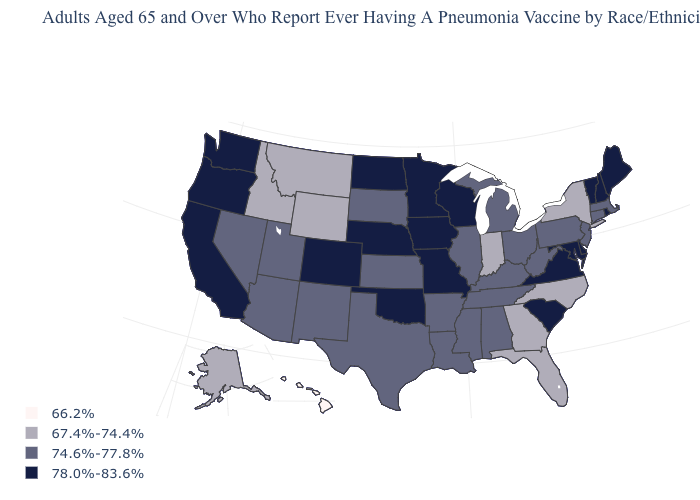Does Washington have the lowest value in the USA?
Keep it brief. No. Which states have the lowest value in the MidWest?
Answer briefly. Indiana. Does the map have missing data?
Quick response, please. No. Name the states that have a value in the range 66.2%?
Be succinct. Hawaii. Which states have the highest value in the USA?
Short answer required. California, Colorado, Delaware, Iowa, Maine, Maryland, Minnesota, Missouri, Nebraska, New Hampshire, North Dakota, Oklahoma, Oregon, Rhode Island, South Carolina, Vermont, Virginia, Washington, Wisconsin. Which states have the lowest value in the USA?
Write a very short answer. Hawaii. What is the value of Oregon?
Keep it brief. 78.0%-83.6%. Which states hav the highest value in the South?
Short answer required. Delaware, Maryland, Oklahoma, South Carolina, Virginia. What is the lowest value in the Northeast?
Concise answer only. 67.4%-74.4%. What is the value of Rhode Island?
Answer briefly. 78.0%-83.6%. Does Colorado have the highest value in the West?
Answer briefly. Yes. Name the states that have a value in the range 66.2%?
Quick response, please. Hawaii. What is the highest value in the USA?
Answer briefly. 78.0%-83.6%. What is the value of Rhode Island?
Answer briefly. 78.0%-83.6%. Name the states that have a value in the range 66.2%?
Be succinct. Hawaii. 